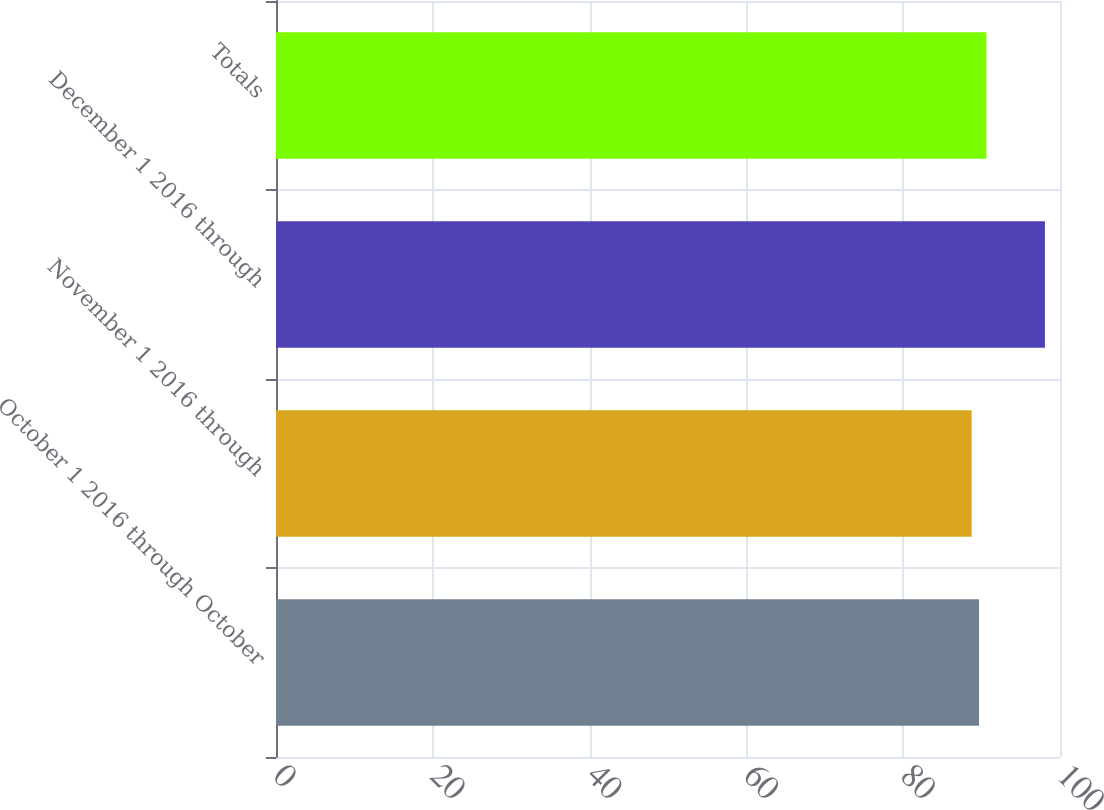<chart> <loc_0><loc_0><loc_500><loc_500><bar_chart><fcel>October 1 2016 through October<fcel>November 1 2016 through<fcel>December 1 2016 through<fcel>Totals<nl><fcel>89.67<fcel>88.73<fcel>98.08<fcel>90.61<nl></chart> 